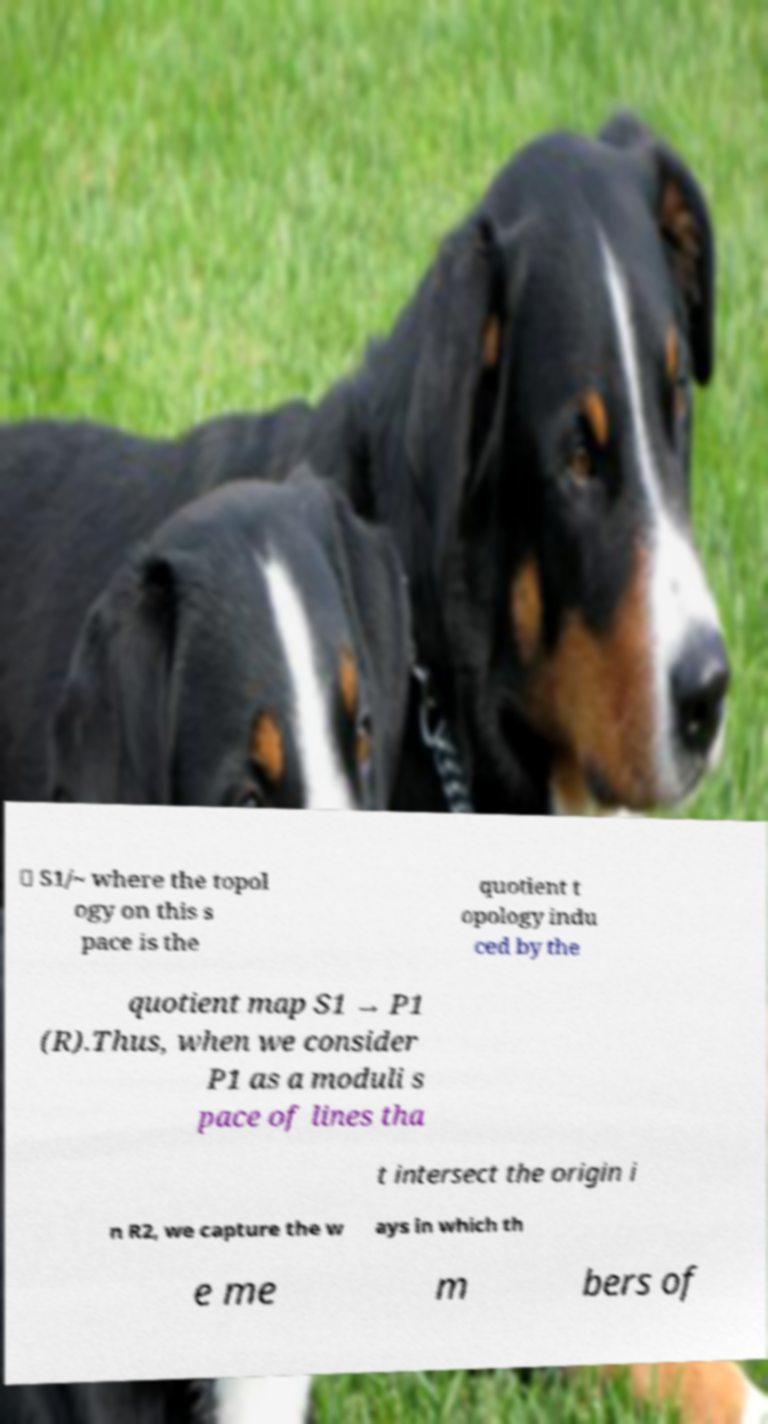Please identify and transcribe the text found in this image. ≅ S1/~ where the topol ogy on this s pace is the quotient t opology indu ced by the quotient map S1 → P1 (R).Thus, when we consider P1 as a moduli s pace of lines tha t intersect the origin i n R2, we capture the w ays in which th e me m bers of 